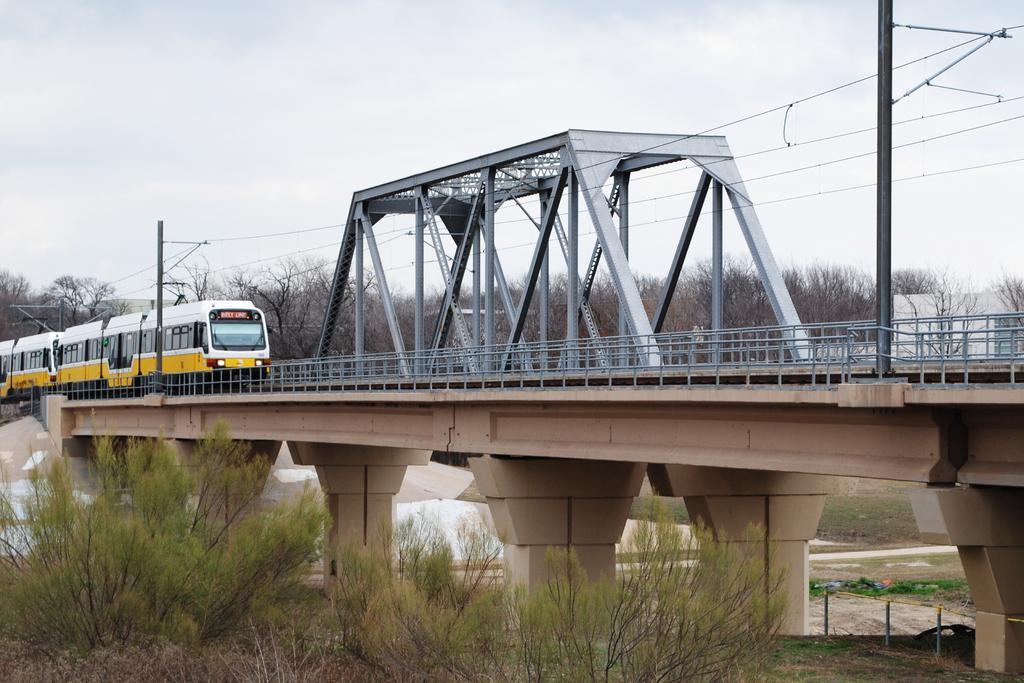In one or two sentences, can you explain what this image depicts? In the picture I can see the railway bridge construction in the middle of the image. I can see a train on the railway track. I can see the trees at the bottom of the image. In the background, I can see the trees. There are clouds in the sky. 